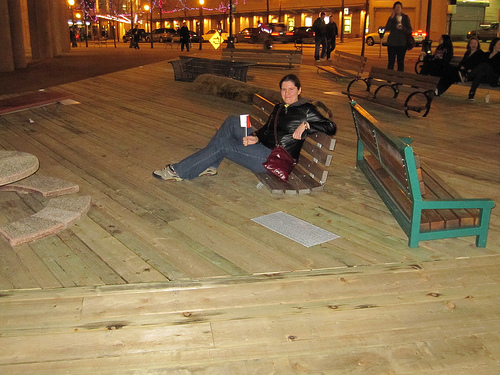<image>
Is there a human behind the bench? No. The human is not behind the bench. From this viewpoint, the human appears to be positioned elsewhere in the scene. 